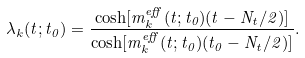Convert formula to latex. <formula><loc_0><loc_0><loc_500><loc_500>\lambda _ { k } ( t ; t _ { 0 } ) = \frac { \cosh [ m ^ { e f f } _ { k } ( t ; t _ { 0 } ) ( t - N _ { t } / 2 ) ] } { \cosh [ m ^ { e f f } _ { k } ( t ; t _ { 0 } ) ( t _ { 0 } - N _ { t } / 2 ) ] } .</formula> 